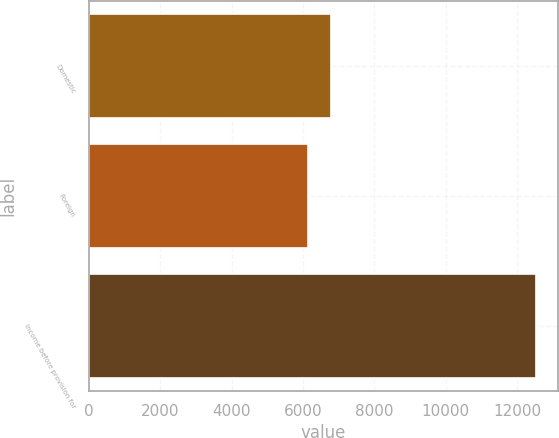<chart> <loc_0><loc_0><loc_500><loc_500><bar_chart><fcel>Domestic<fcel>Foreign<fcel>Income before provision for<nl><fcel>6786.8<fcel>6150<fcel>12518<nl></chart> 